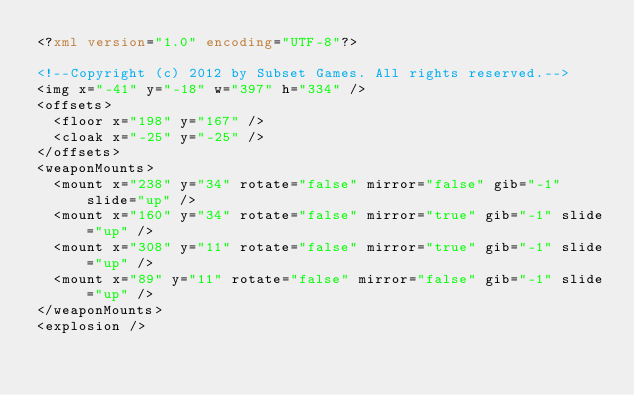Convert code to text. <code><loc_0><loc_0><loc_500><loc_500><_XML_><?xml version="1.0" encoding="UTF-8"?>

<!--Copyright (c) 2012 by Subset Games. All rights reserved.-->
<img x="-41" y="-18" w="397" h="334" />
<offsets>
	<floor x="198" y="167" />
	<cloak x="-25" y="-25" />
</offsets>
<weaponMounts>
	<mount x="238" y="34" rotate="false" mirror="false" gib="-1" slide="up" />
	<mount x="160" y="34" rotate="false" mirror="true" gib="-1" slide="up" />
	<mount x="308" y="11" rotate="false" mirror="true" gib="-1" slide="up" />
	<mount x="89" y="11" rotate="false" mirror="false" gib="-1" slide="up" />
</weaponMounts>
<explosion />

</code> 